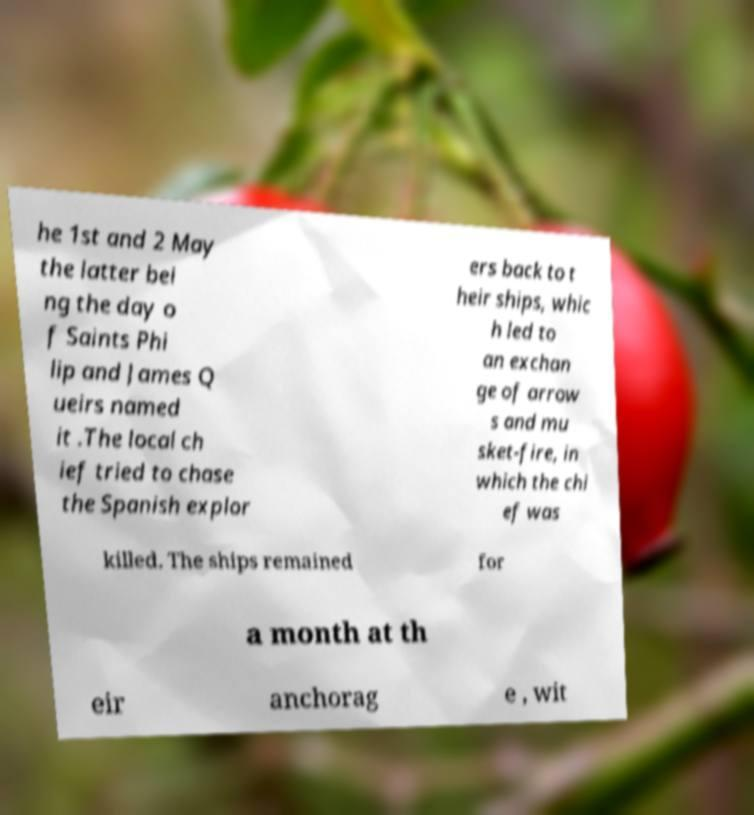For documentation purposes, I need the text within this image transcribed. Could you provide that? he 1st and 2 May the latter bei ng the day o f Saints Phi lip and James Q ueirs named it .The local ch ief tried to chase the Spanish explor ers back to t heir ships, whic h led to an exchan ge of arrow s and mu sket-fire, in which the chi ef was killed. The ships remained for a month at th eir anchorag e , wit 